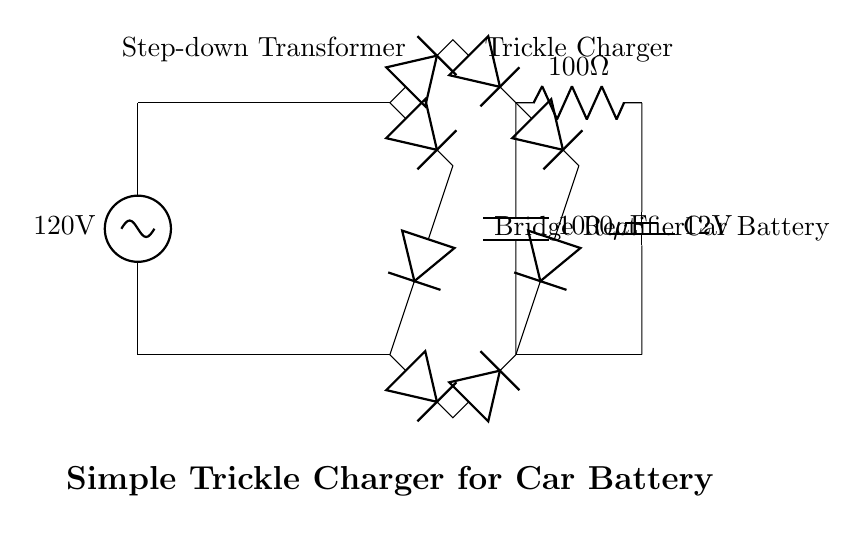What is the voltage source in the circuit? The voltage source in the circuit is labeled as 120 volts, which is indicated at the top of the circuit diagram.
Answer: 120 volts What type of component is used to reduce the voltage? The component used to reduce the voltage is a transformer, specifically a step-down transformer, which is marked in the circuit between the voltage source and the other components.
Answer: Transformer How many diodes are in the bridge rectifier? There are four diodes in the bridge rectifier, as seen connected in a specific arrangement to convert AC to DC.
Answer: Four What is the capacitance value of the smoothing capacitor? The smoothing capacitor is labeled with a value of 1000 microfarads, which is specified near the capacitor symbol in the circuit.
Answer: 1000 microfarads What is the role of the current limiting resistor? The current limiting resistor is used to restrict the current flowing to the car battery, ensuring that it does not overcharge. It is indicated in the circuit diagram near the battery.
Answer: Current limiting What is the purpose of this circuit? The purpose of this circuit is to maintain a car battery during long periods of disuse by providing a small charge, which is referred to as trickle charging.
Answer: Trickle charging What is the output voltage of the trickle charger? The output voltage of the trickle charger is 12 volts, which corresponds to the car battery's voltage, shown in the battery symbol on the circuit.
Answer: 12 volts 